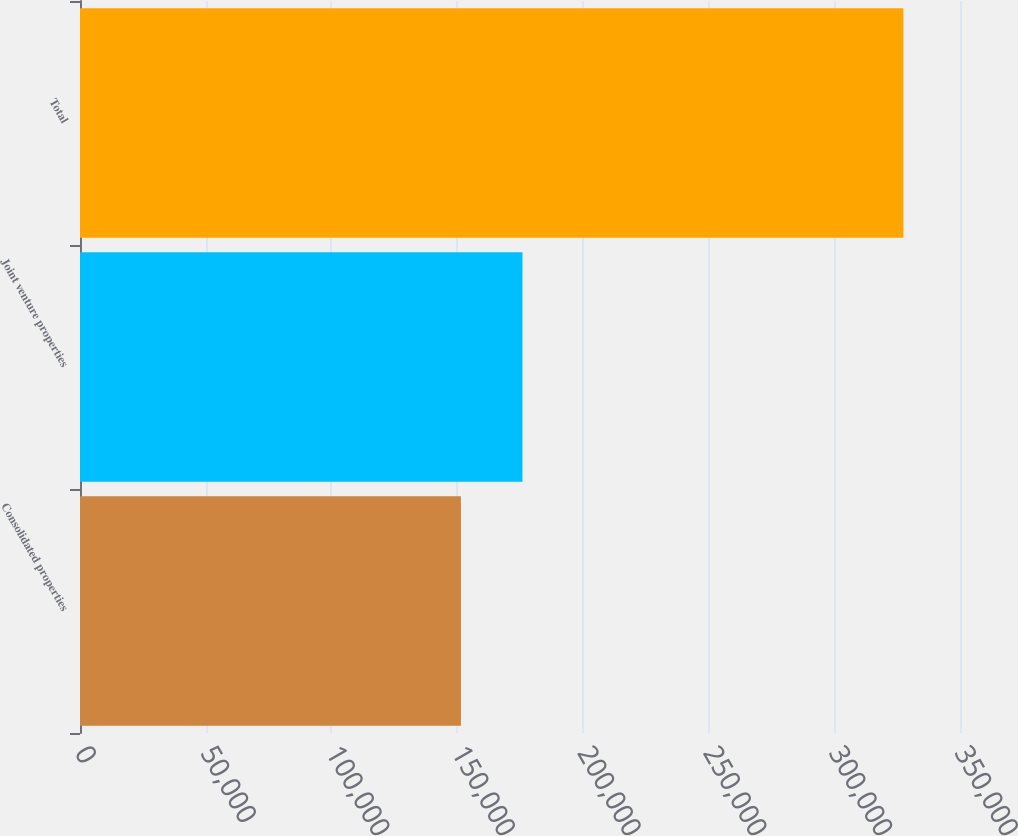Convert chart. <chart><loc_0><loc_0><loc_500><loc_500><bar_chart><fcel>Consolidated properties<fcel>Joint venture properties<fcel>Total<nl><fcel>151502<fcel>175985<fcel>327487<nl></chart> 